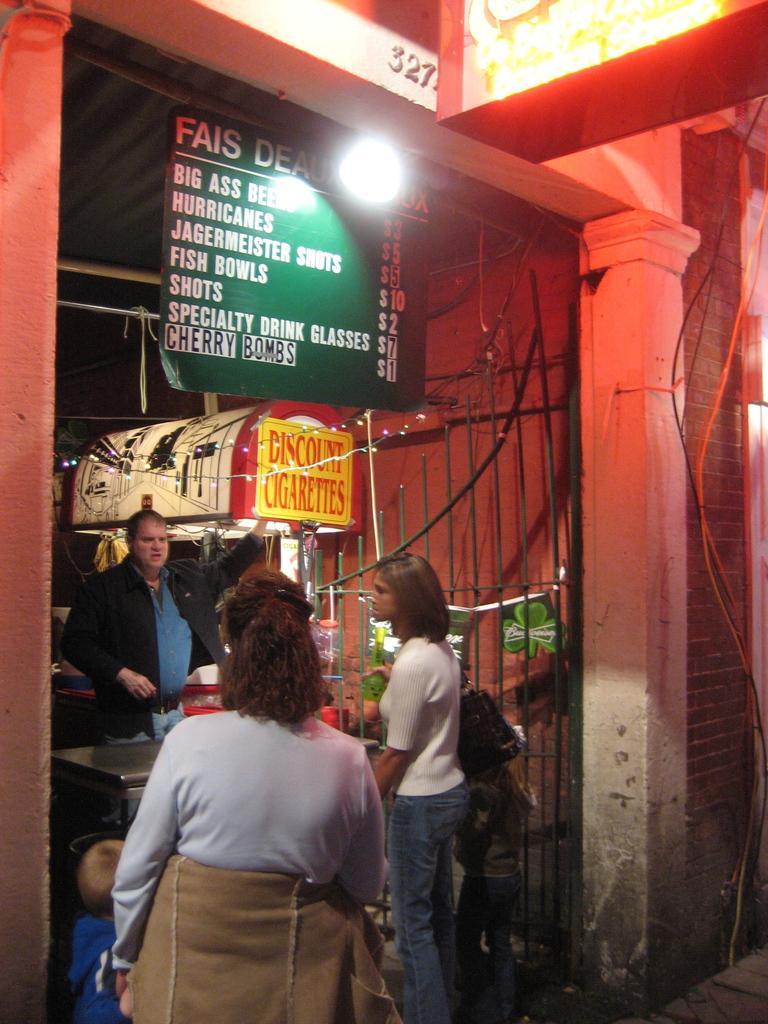Describe this image in one or two sentences. In this picture I can observe three members. Two of them are women and one of them is man. I can observe green and yellow color boards. There is some text on these boards. There is a light on the top of the picture. On the top right side I can observe some lights. 